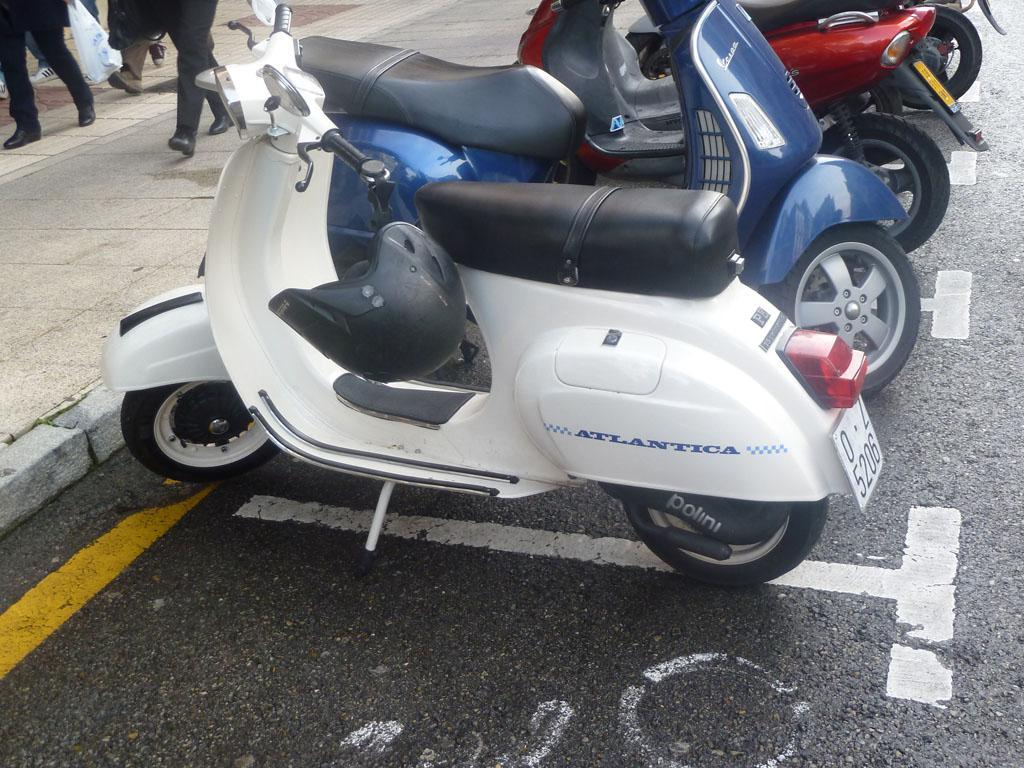What type of protective gear is visible in the image? There is a helmet in the image. What type of disposable container is present in the image? There is a plastic bag in the image. What mode of transportation can be seen on the road in the image? There are motorcycles on the road in the image. What activity are people engaged in on the footpath in the image? There are people walking on the footpath in the image. What type of territory is being claimed by the helmet in the image? There is no territory being claimed by the helmet in the image; it is simply a piece of protective gear. What kind of jewel is embedded in the plastic bag in the image? There is no jewel present in the image; it is a plastic bag. 